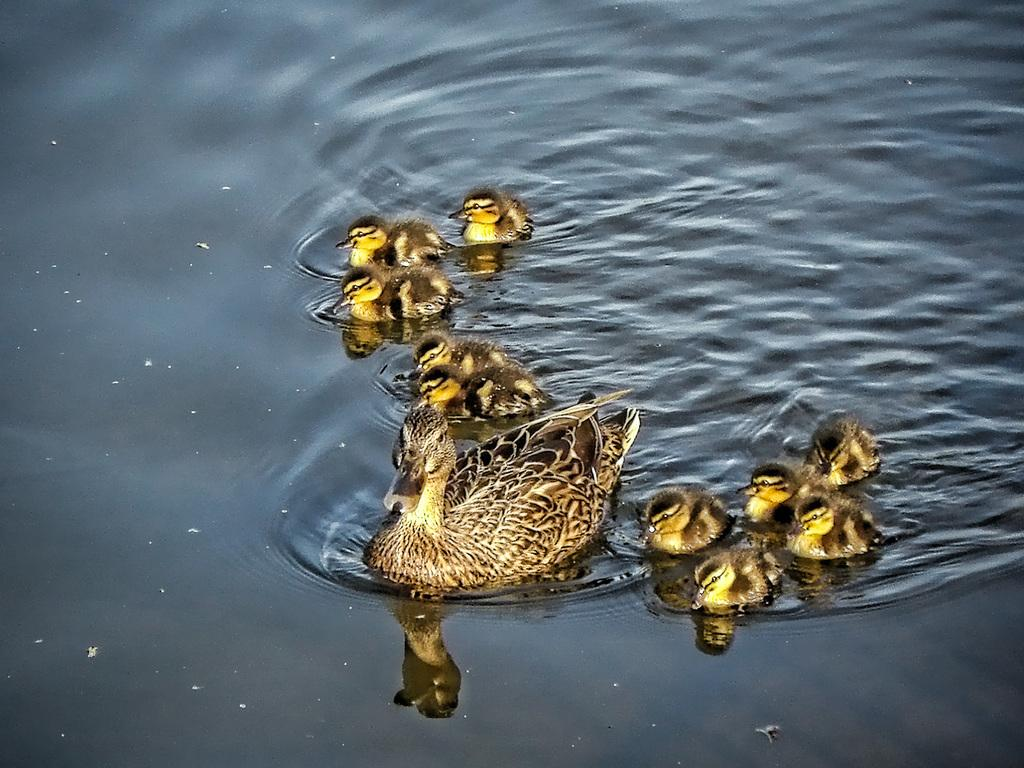What type of animal is present in the image? There is a duck in the image. Are there any other animals in the image? Yes, there are ducklings in the image. Where are the duck and ducklings located? The duck and ducklings are in the water. How many chairs can be seen in the image? There are no chairs present in the image. What type of snail is visible in the image? There is no snail present in the image. 